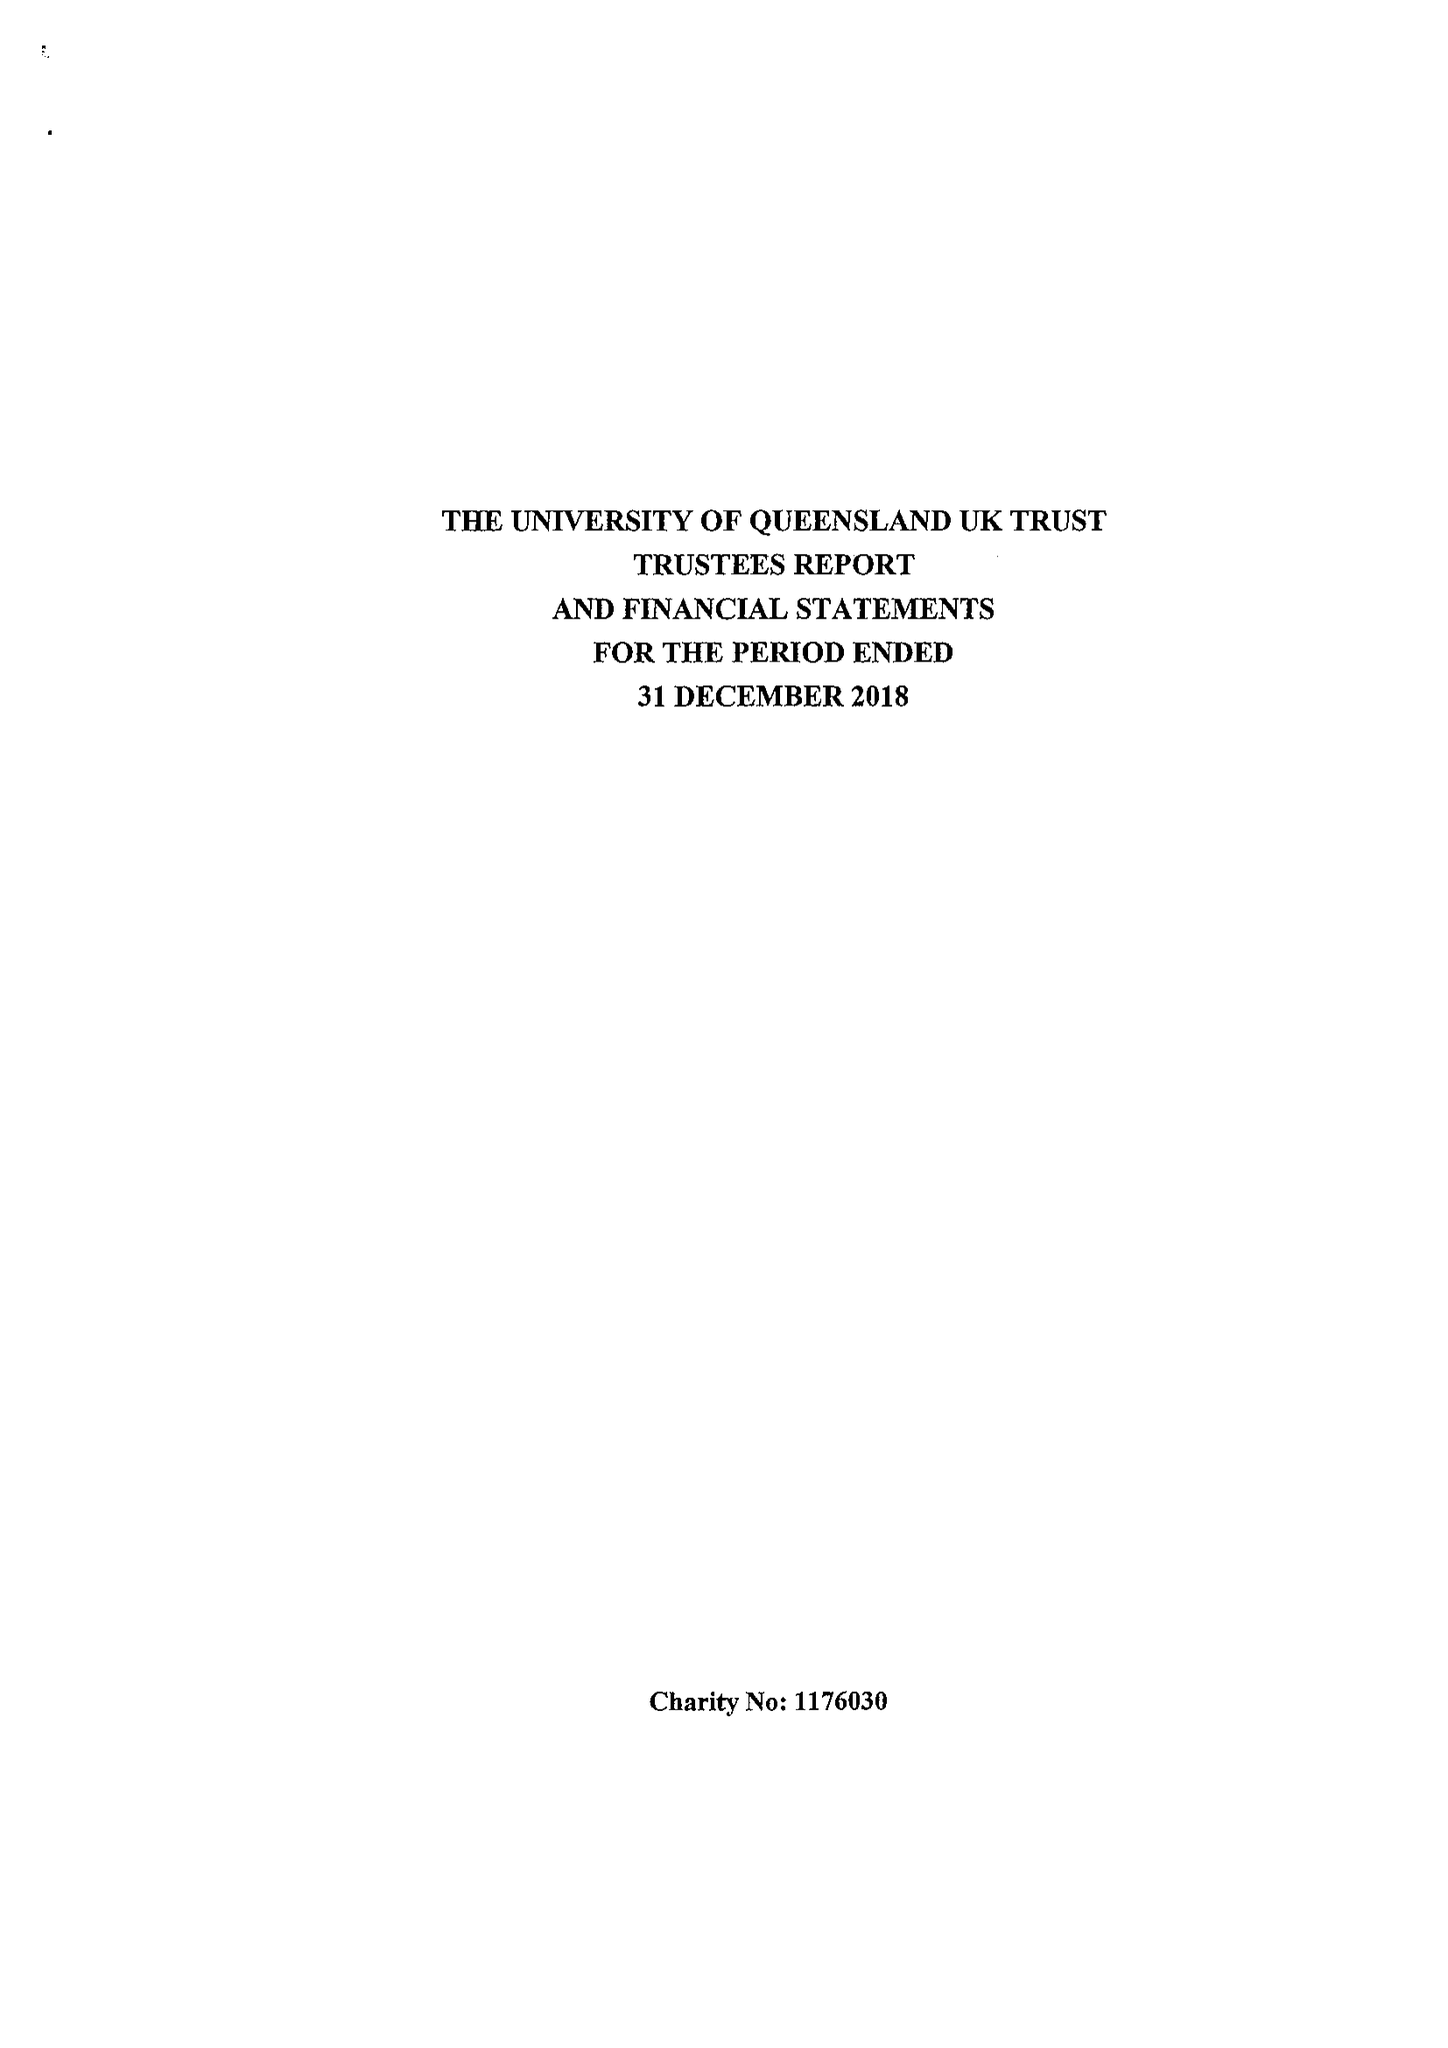What is the value for the report_date?
Answer the question using a single word or phrase. 2018-12-31 